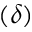<formula> <loc_0><loc_0><loc_500><loc_500>( \delta )</formula> 